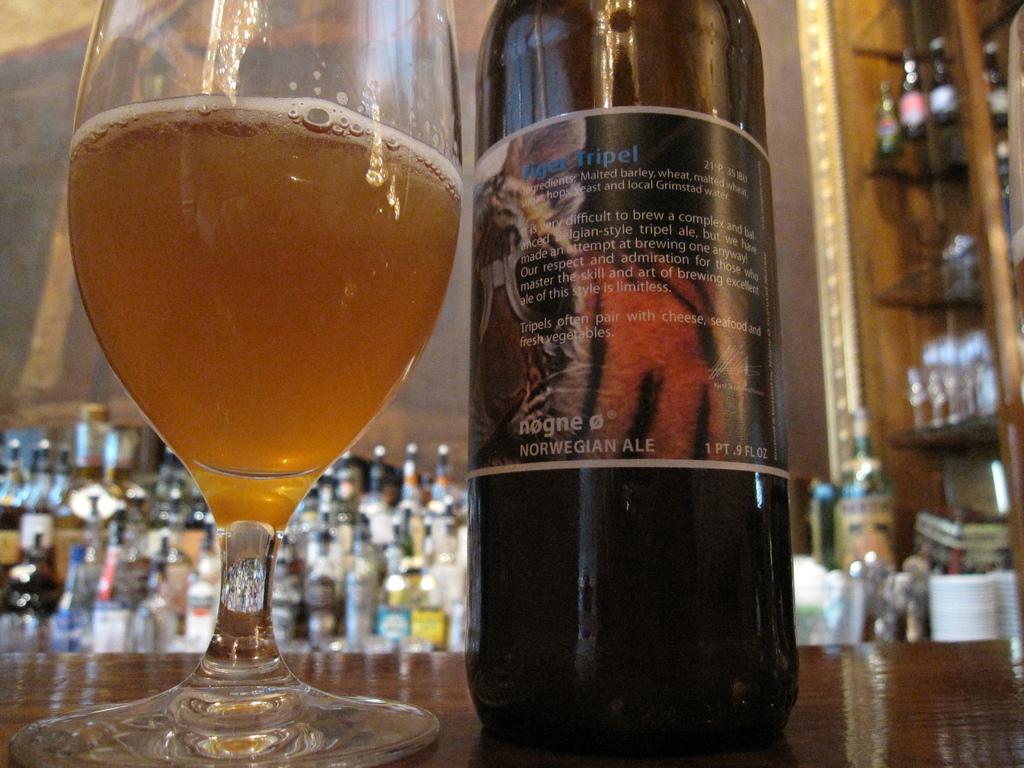What kind of wine is that?
Offer a terse response. Norwegian ale. How many pints is this bottle?
Make the answer very short. 1. 